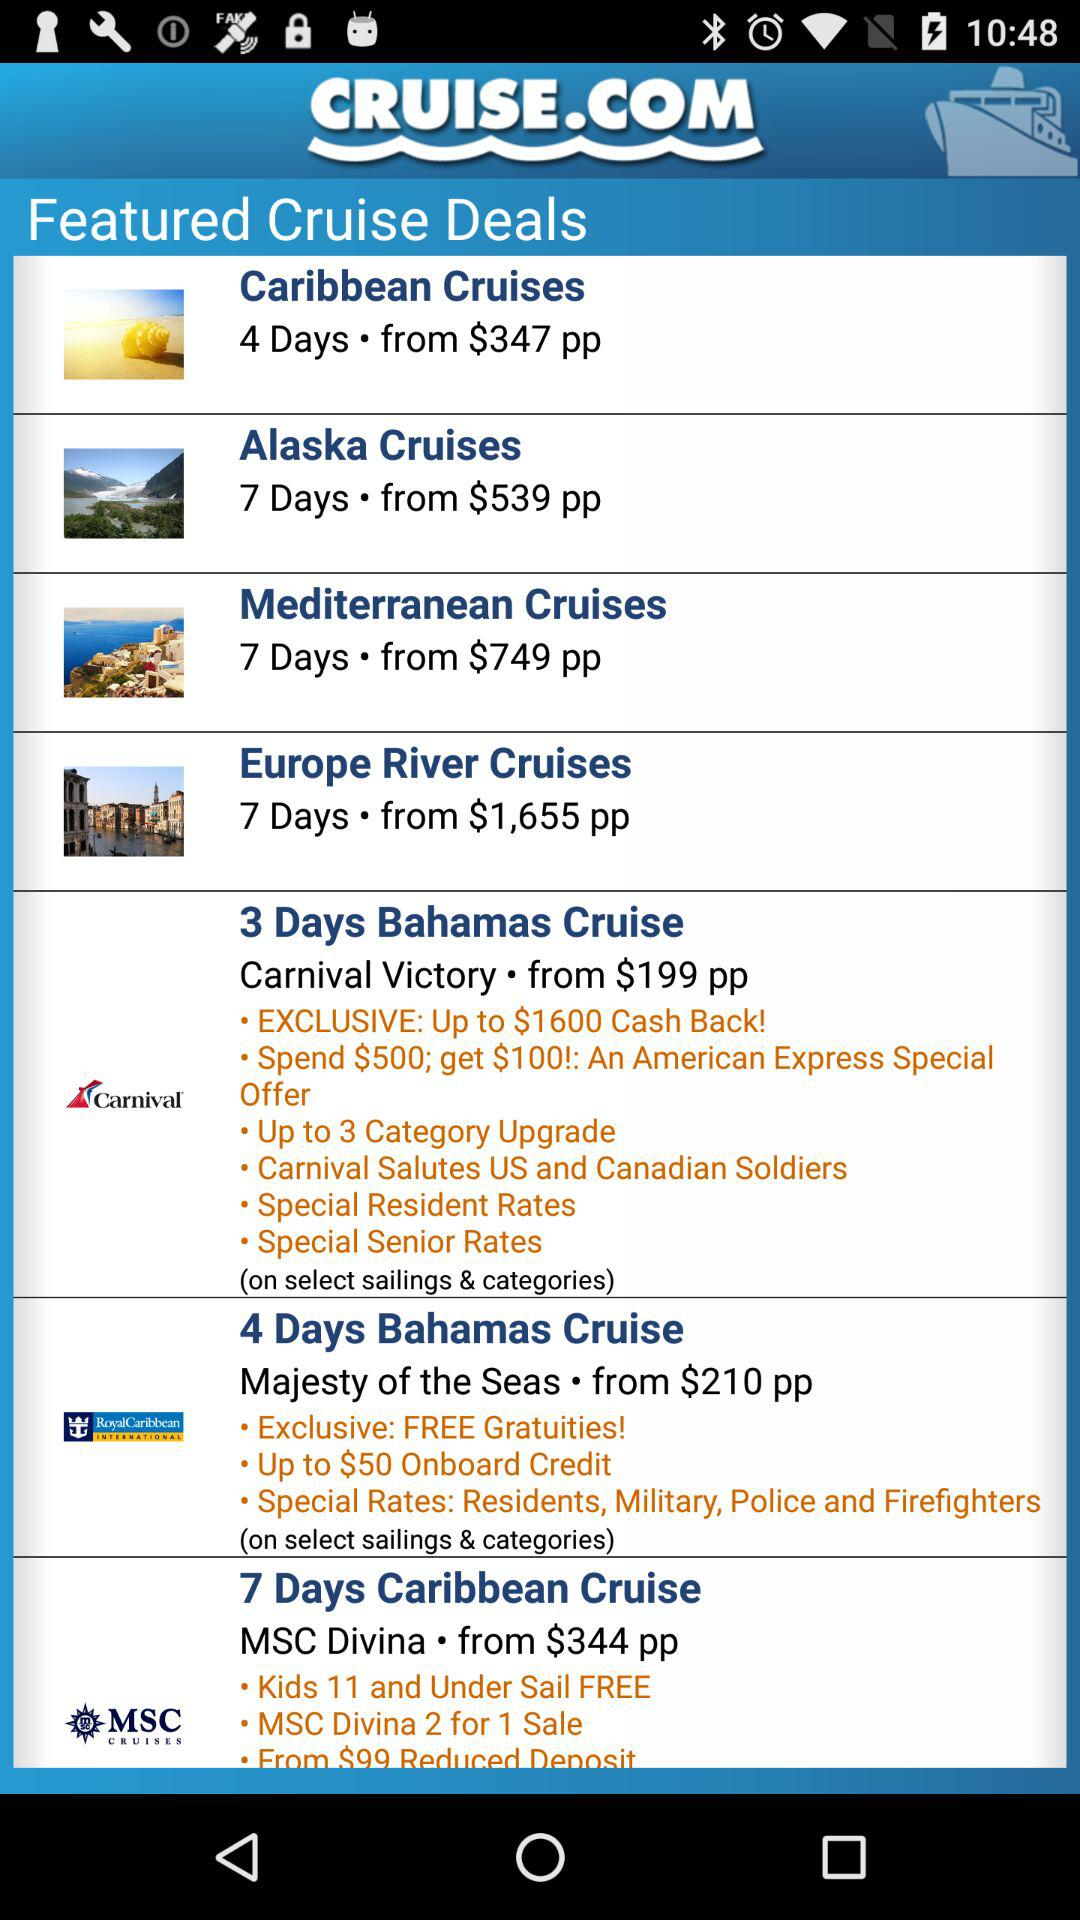What is the time duration of the "Bahamas Cruise" trip on "Carnival Victory"? The time duration of the "Bahamas Cruise" trip on "Carnival Victory" is 3 days. 